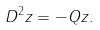<formula> <loc_0><loc_0><loc_500><loc_500>D ^ { 2 } z = - Q z .</formula> 